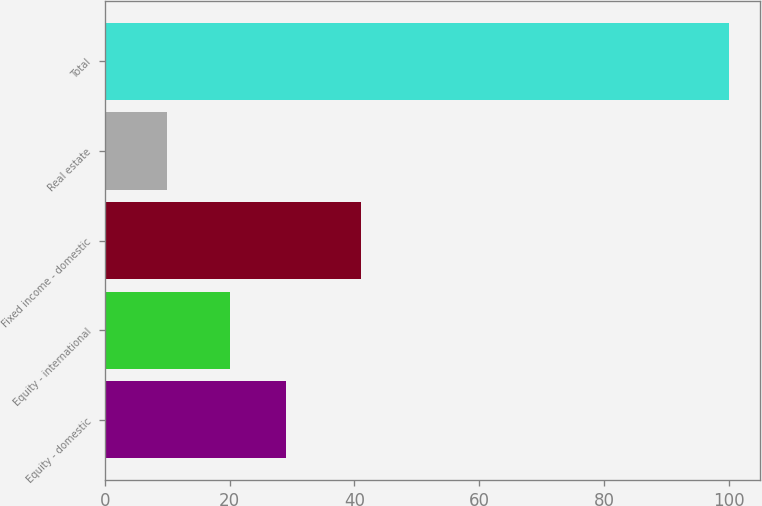Convert chart to OTSL. <chart><loc_0><loc_0><loc_500><loc_500><bar_chart><fcel>Equity - domestic<fcel>Equity - international<fcel>Fixed income - domestic<fcel>Real estate<fcel>Total<nl><fcel>29<fcel>20<fcel>41<fcel>10<fcel>100<nl></chart> 